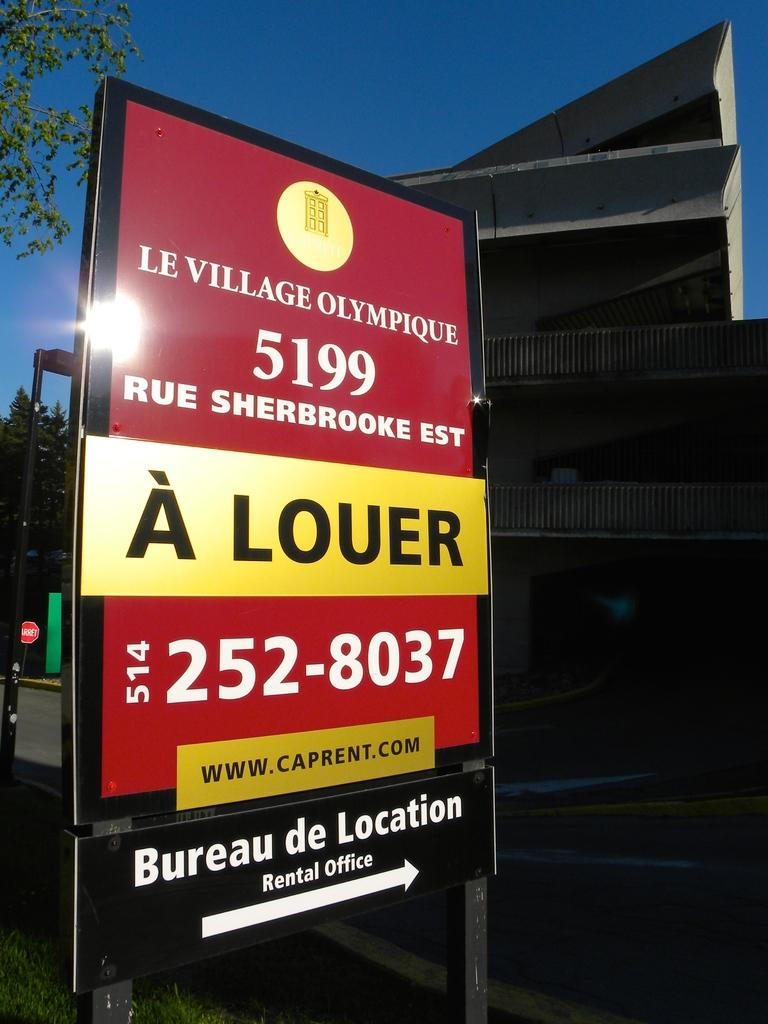<image>
Describe the image concisely. A sign on the side of the road indicates the location of the rental office of an apartment complex called Le Village Olympique. 